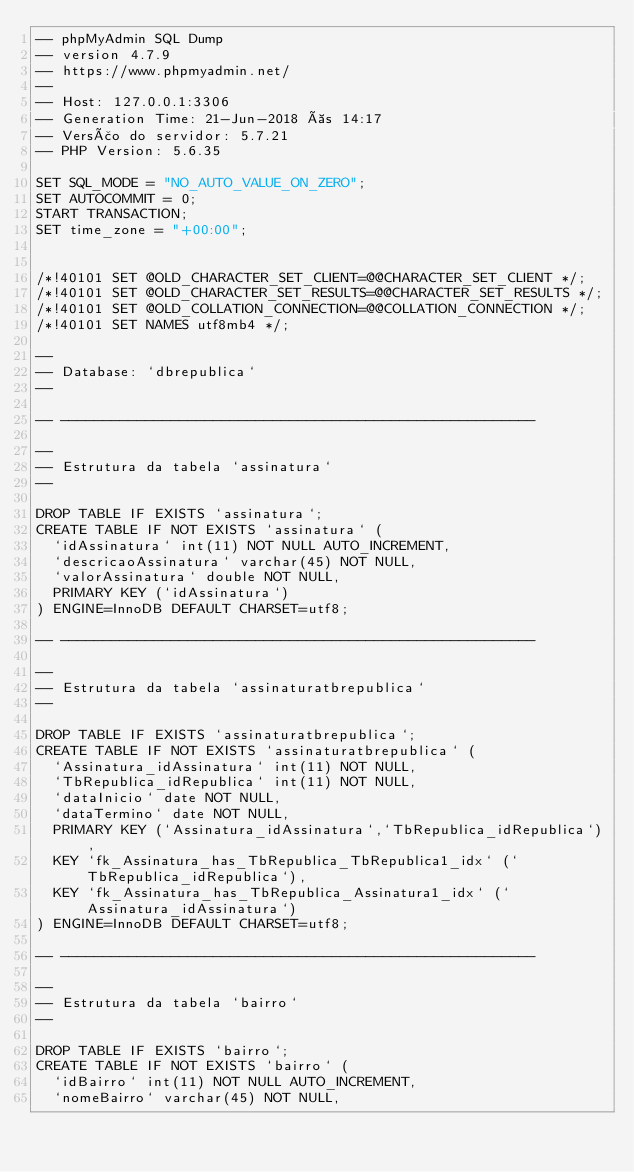Convert code to text. <code><loc_0><loc_0><loc_500><loc_500><_SQL_>-- phpMyAdmin SQL Dump
-- version 4.7.9
-- https://www.phpmyadmin.net/
--
-- Host: 127.0.0.1:3306
-- Generation Time: 21-Jun-2018 às 14:17
-- Versão do servidor: 5.7.21
-- PHP Version: 5.6.35

SET SQL_MODE = "NO_AUTO_VALUE_ON_ZERO";
SET AUTOCOMMIT = 0;
START TRANSACTION;
SET time_zone = "+00:00";


/*!40101 SET @OLD_CHARACTER_SET_CLIENT=@@CHARACTER_SET_CLIENT */;
/*!40101 SET @OLD_CHARACTER_SET_RESULTS=@@CHARACTER_SET_RESULTS */;
/*!40101 SET @OLD_COLLATION_CONNECTION=@@COLLATION_CONNECTION */;
/*!40101 SET NAMES utf8mb4 */;

--
-- Database: `dbrepublica`
--

-- --------------------------------------------------------

--
-- Estrutura da tabela `assinatura`
--

DROP TABLE IF EXISTS `assinatura`;
CREATE TABLE IF NOT EXISTS `assinatura` (
  `idAssinatura` int(11) NOT NULL AUTO_INCREMENT,
  `descricaoAssinatura` varchar(45) NOT NULL,
  `valorAssinatura` double NOT NULL,
  PRIMARY KEY (`idAssinatura`)
) ENGINE=InnoDB DEFAULT CHARSET=utf8;

-- --------------------------------------------------------

--
-- Estrutura da tabela `assinaturatbrepublica`
--

DROP TABLE IF EXISTS `assinaturatbrepublica`;
CREATE TABLE IF NOT EXISTS `assinaturatbrepublica` (
  `Assinatura_idAssinatura` int(11) NOT NULL,
  `TbRepublica_idRepublica` int(11) NOT NULL,
  `dataInicio` date NOT NULL,
  `dataTermino` date NOT NULL,
  PRIMARY KEY (`Assinatura_idAssinatura`,`TbRepublica_idRepublica`),
  KEY `fk_Assinatura_has_TbRepublica_TbRepublica1_idx` (`TbRepublica_idRepublica`),
  KEY `fk_Assinatura_has_TbRepublica_Assinatura1_idx` (`Assinatura_idAssinatura`)
) ENGINE=InnoDB DEFAULT CHARSET=utf8;

-- --------------------------------------------------------

--
-- Estrutura da tabela `bairro`
--

DROP TABLE IF EXISTS `bairro`;
CREATE TABLE IF NOT EXISTS `bairro` (
  `idBairro` int(11) NOT NULL AUTO_INCREMENT,
  `nomeBairro` varchar(45) NOT NULL,</code> 